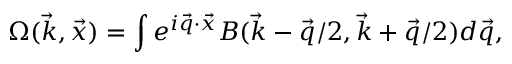Convert formula to latex. <formula><loc_0><loc_0><loc_500><loc_500>\Omega ( \vec { k } , \vec { x } ) = \int e ^ { i \vec { q } \cdot \vec { x } } B ( \vec { k } - \vec { q } / 2 , \vec { k } + \vec { q } / 2 ) d \vec { q } ,</formula> 